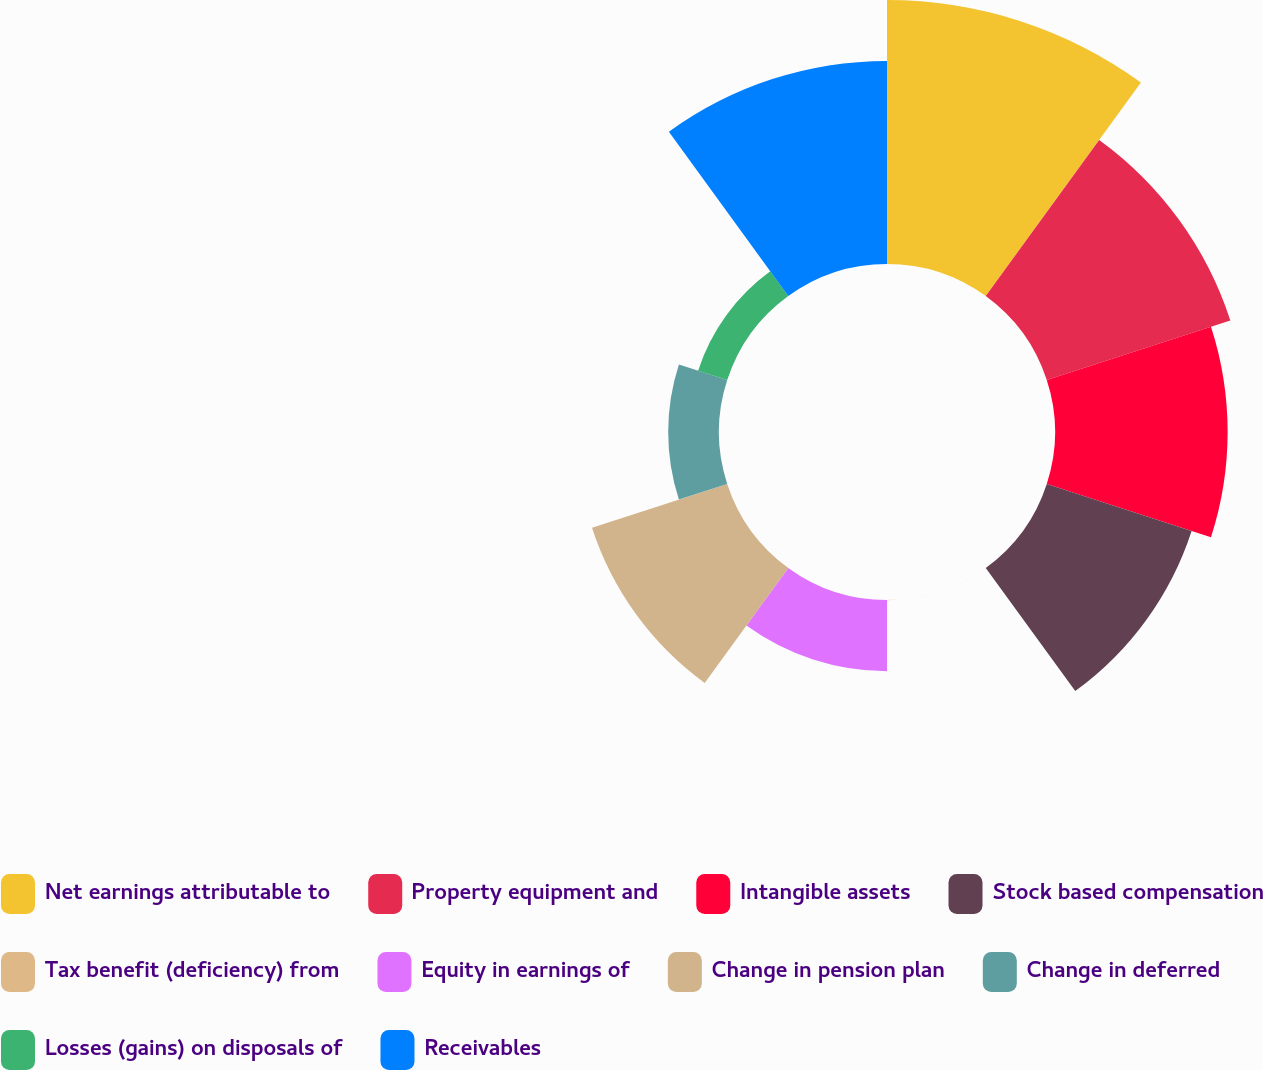Convert chart to OTSL. <chart><loc_0><loc_0><loc_500><loc_500><pie_chart><fcel>Net earnings attributable to<fcel>Property equipment and<fcel>Intangible assets<fcel>Stock based compensation<fcel>Tax benefit (deficiency) from<fcel>Equity in earnings of<fcel>Change in pension plan<fcel>Change in deferred<fcel>Losses (gains) on disposals of<fcel>Receivables<nl><fcel>20.63%<fcel>15.08%<fcel>13.49%<fcel>11.9%<fcel>0.01%<fcel>5.56%<fcel>11.11%<fcel>3.97%<fcel>2.39%<fcel>15.87%<nl></chart> 